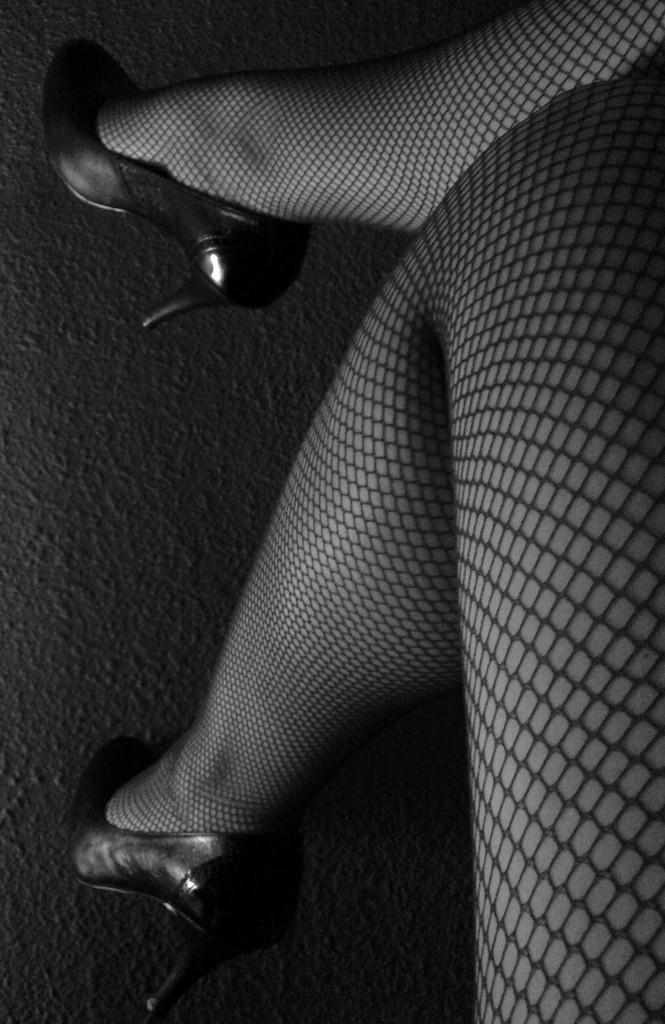Please provide a concise description of this image. In this picture a person legs are visible. She is wearing footwear to her legs. Background there is a floor. 